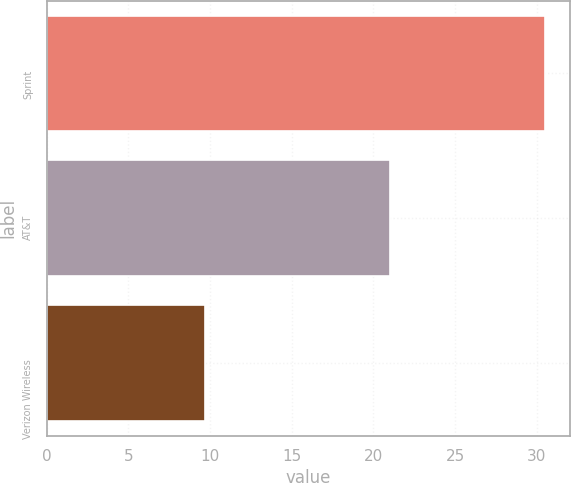Convert chart. <chart><loc_0><loc_0><loc_500><loc_500><bar_chart><fcel>Sprint<fcel>AT&T<fcel>Verizon Wireless<nl><fcel>30.5<fcel>21<fcel>9.7<nl></chart> 